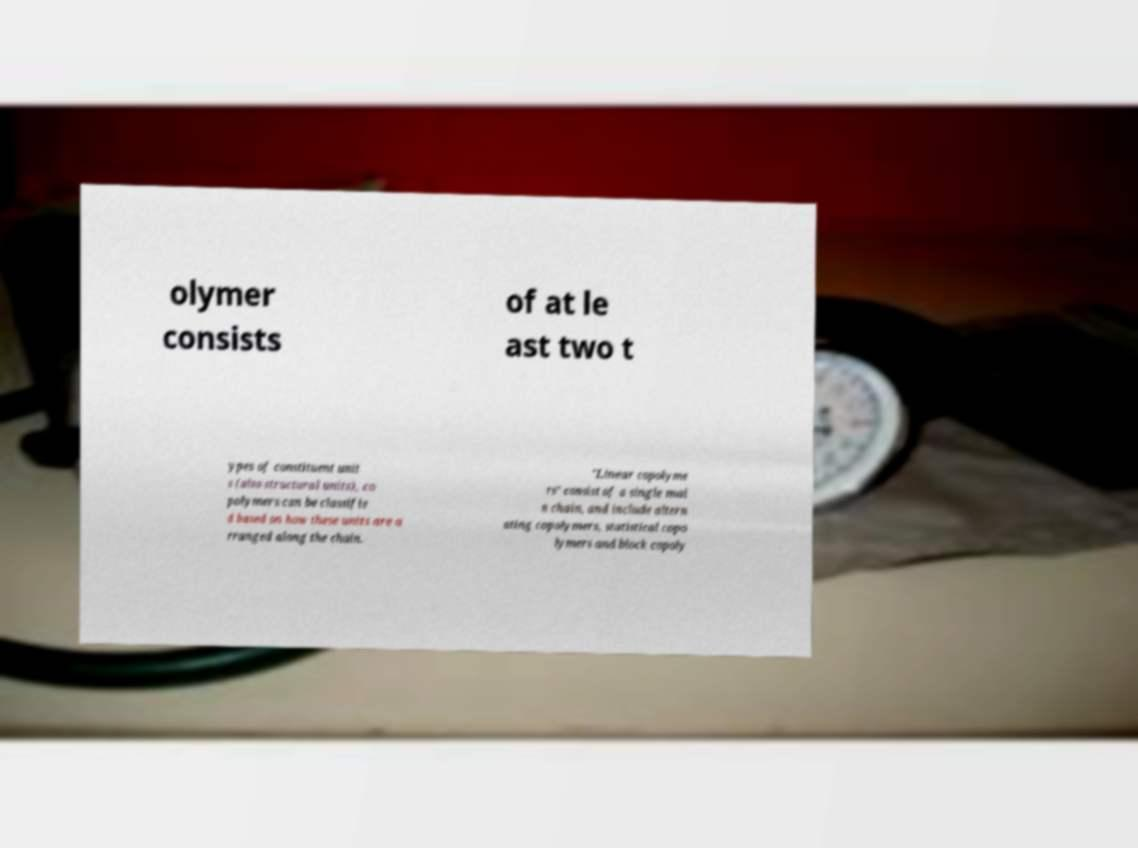There's text embedded in this image that I need extracted. Can you transcribe it verbatim? olymer consists of at le ast two t ypes of constituent unit s (also structural units), co polymers can be classifie d based on how these units are a rranged along the chain. "Linear copolyme rs" consist of a single mai n chain, and include altern ating copolymers, statistical copo lymers and block copoly 